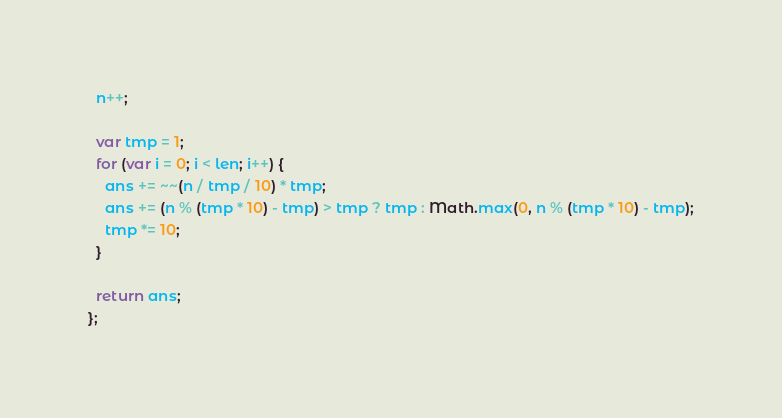<code> <loc_0><loc_0><loc_500><loc_500><_JavaScript_>  n++;

  var tmp = 1;
  for (var i = 0; i < len; i++) {
    ans += ~~(n / tmp / 10) * tmp;
    ans += (n % (tmp * 10) - tmp) > tmp ? tmp : Math.max(0, n % (tmp * 10) - tmp);
    tmp *= 10;
  }

  return ans;
};</code> 